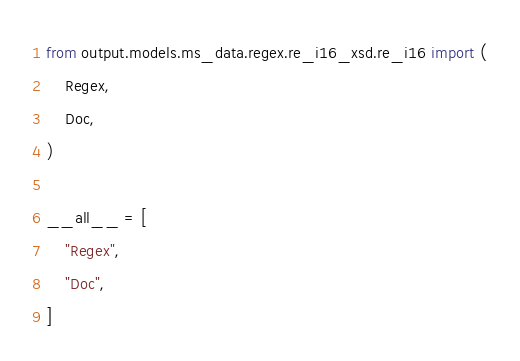<code> <loc_0><loc_0><loc_500><loc_500><_Python_>from output.models.ms_data.regex.re_i16_xsd.re_i16 import (
    Regex,
    Doc,
)

__all__ = [
    "Regex",
    "Doc",
]
</code> 